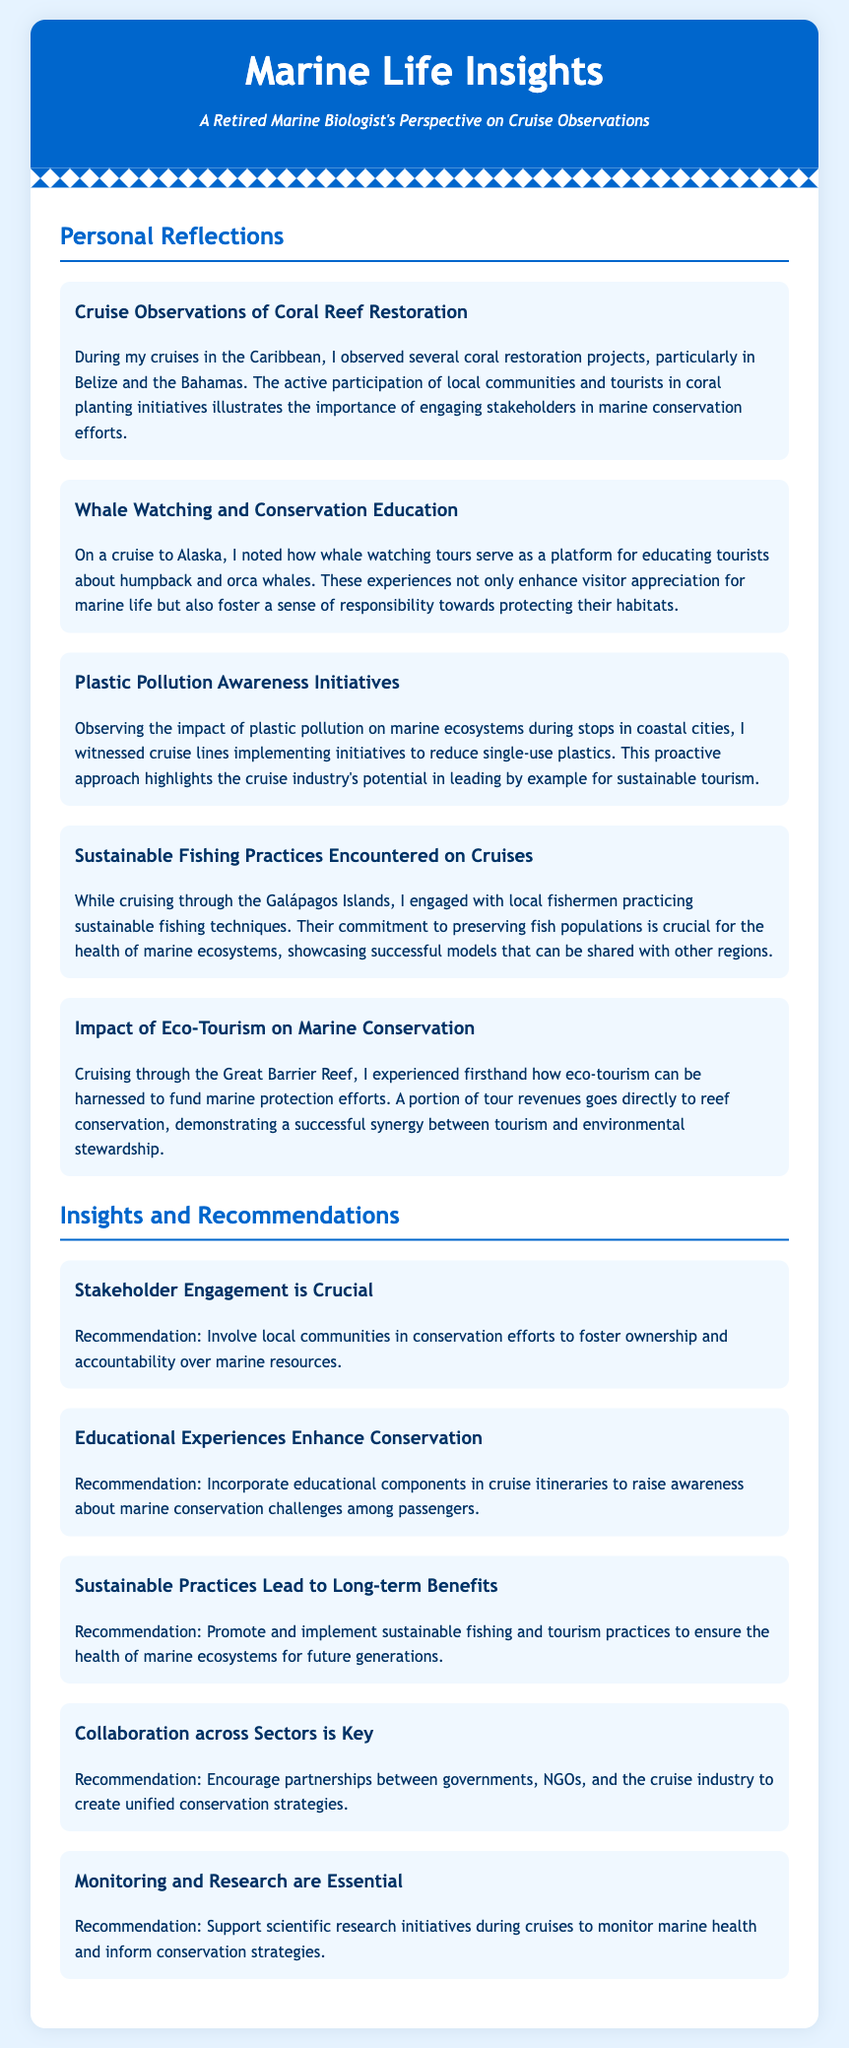what is the title of the document? The title of the document is prominently displayed at the top of the header.
Answer: Marine Life Insights how many personal reflections are included? The number of personal reflections is indicated by the count of sections under Personal Reflections.
Answer: Five which location is associated with whale watching tours? The location where whale watching tours are particularly highlighted is mentioned in the description of the related reflection.
Answer: Alaska what is one of the sustainable practices noted in the Galápagos Islands? The sustainable practices are described in a specific reflection relating to fishermen.
Answer: Sustainable fishing techniques what recommendation is made regarding stakeholder engagement? The specific recommendation is provided in a section focusing on insights and recommendations.
Answer: Involve local communities which marine conservation challenge is recommended to raise awareness about? The specific challenge mentioned is part of the educational component recommendation in the insights.
Answer: Marine conservation challenges how does eco-tourism contribute to marine conservation according to the document? The document specifies how eco-tourism is beneficial in a particular context within the insights section.
Answer: Funds marine protection efforts what does the reflection on plastic pollution mention about cruise lines? The reflection highlights specific actions taken by cruise lines regarding a prevalent issue.
Answer: Implementing initiatives to reduce single-use plastics what is recommended for monitoring marine health? The recommendation related to monitoring is stated clearly within the insights section.
Answer: Support scientific research initiatives 